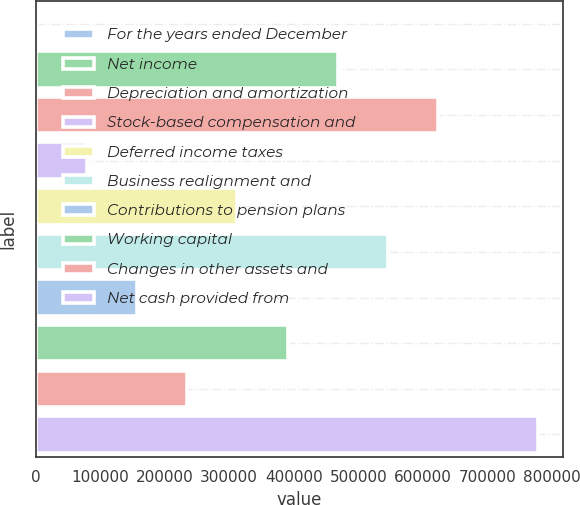Convert chart to OTSL. <chart><loc_0><loc_0><loc_500><loc_500><bar_chart><fcel>For the years ended December<fcel>Net income<fcel>Depreciation and amortization<fcel>Stock-based compensation and<fcel>Deferred income taxes<fcel>Business realignment and<fcel>Contributions to pension plans<fcel>Working capital<fcel>Changes in other assets and<fcel>Net cash provided from<nl><fcel>2007<fcel>468104<fcel>623470<fcel>79689.9<fcel>312739<fcel>545787<fcel>157373<fcel>390422<fcel>235056<fcel>778836<nl></chart> 